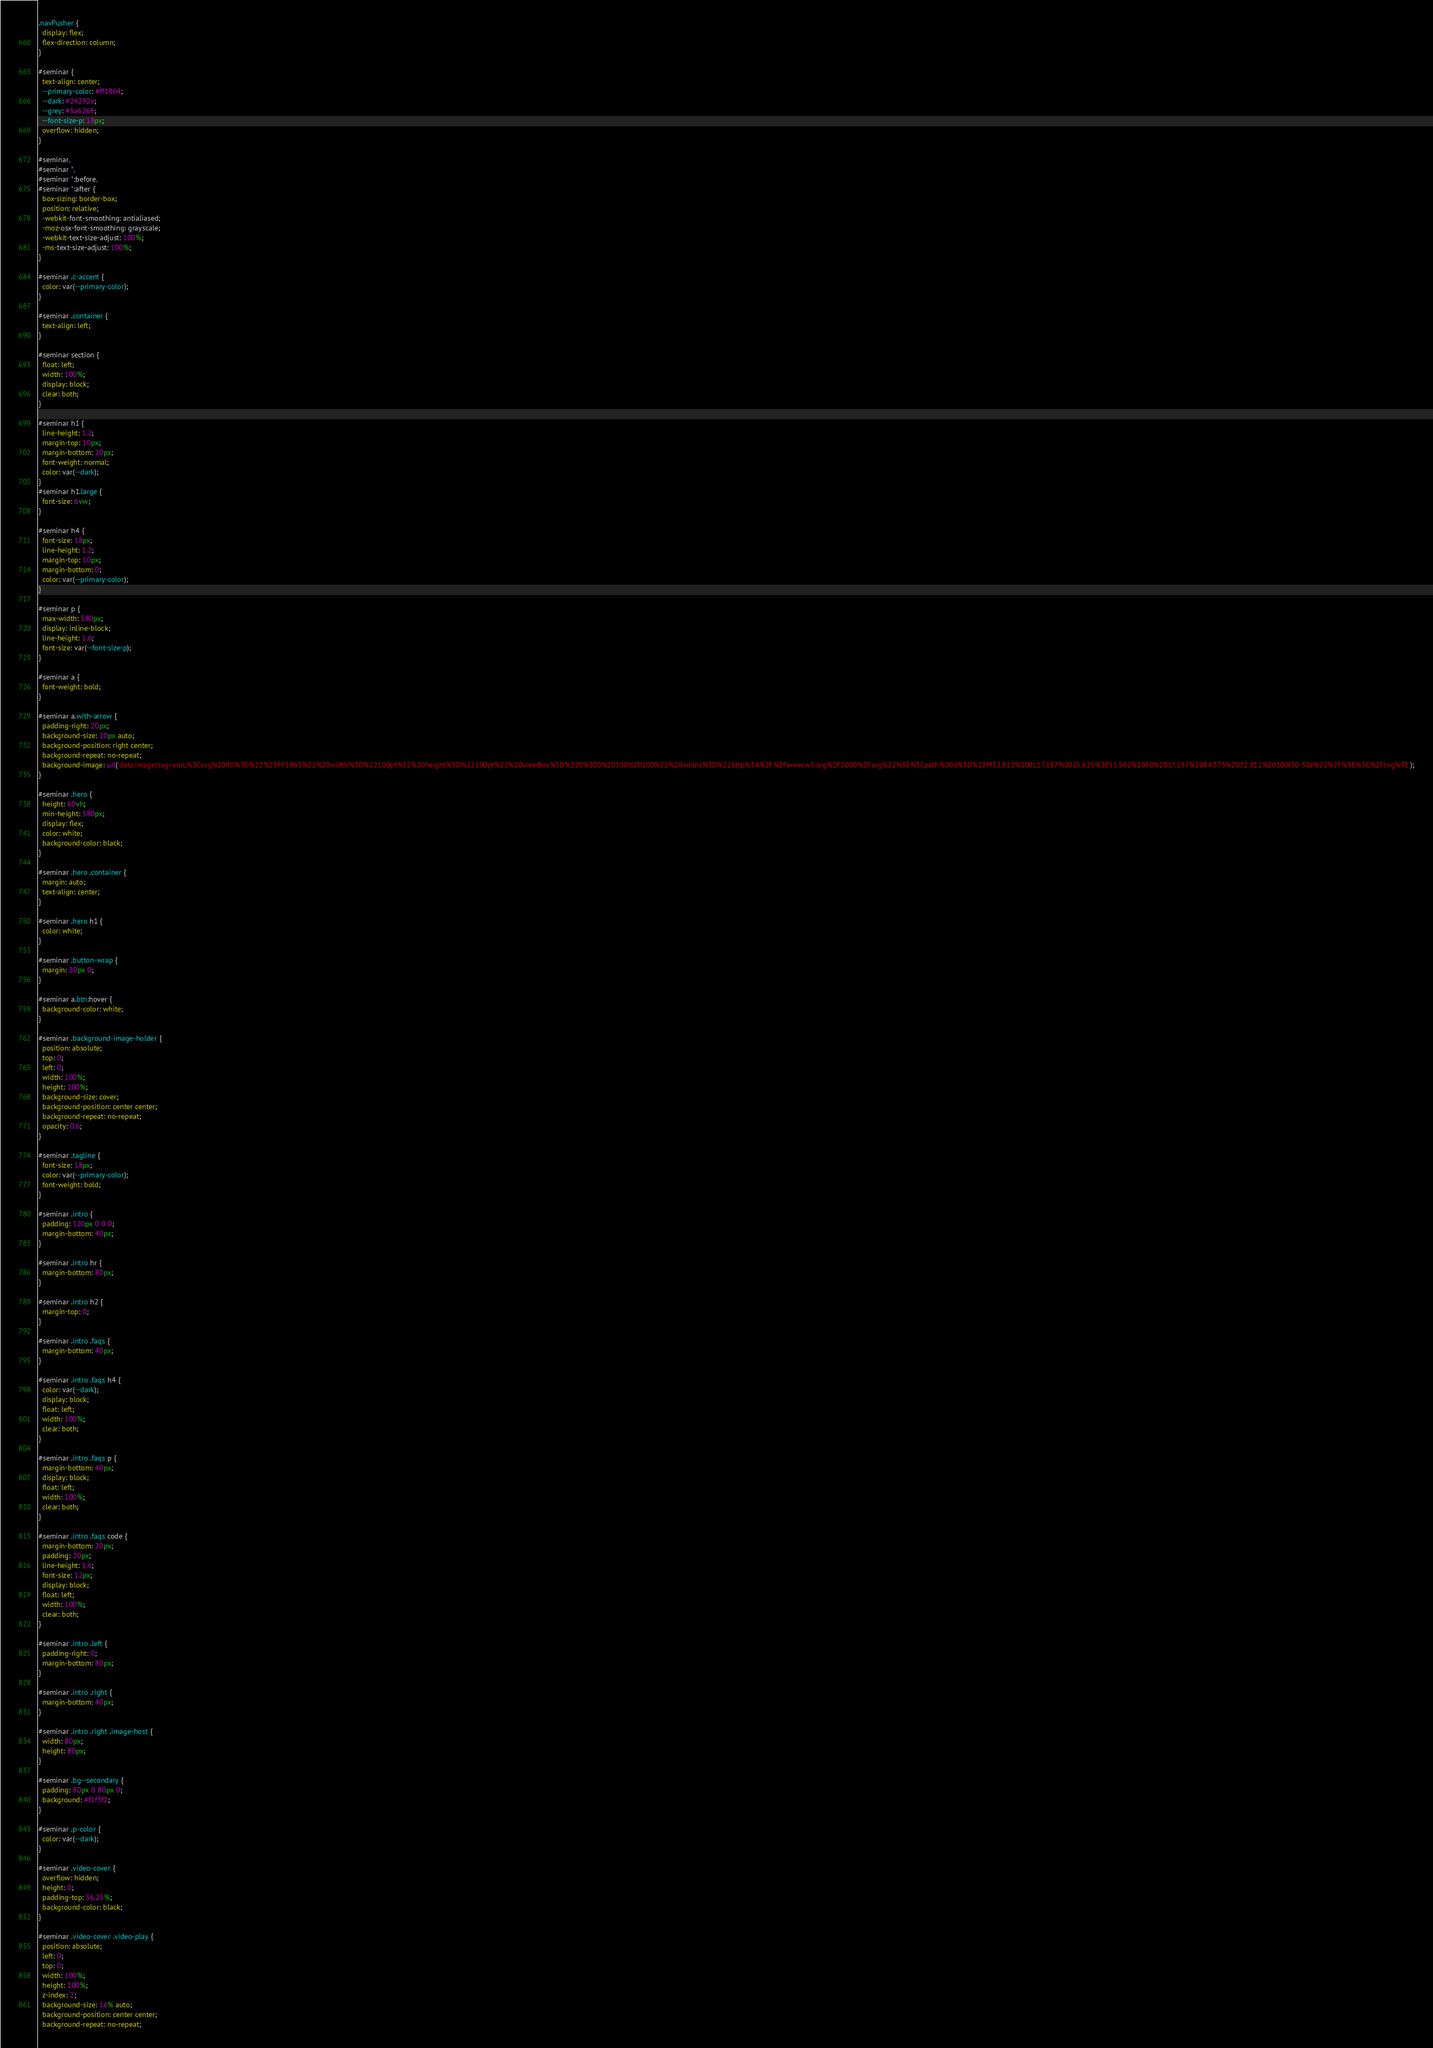<code> <loc_0><loc_0><loc_500><loc_500><_CSS_>.navPusher {
  display: flex;
  flex-direction: column;
}

#seminar {
  text-align: center;
  --primary-color: #ff1864;
  --dark: #24292e;
  --grey: #5a6268;
  --font-size-p: 18px;
  overflow: hidden;
}

#seminar,
#seminar *,
#seminar *:before,
#seminar *:after {
  box-sizing: border-box;
  position: relative;
  -webkit-font-smoothing: antialiased;
  -moz-osx-font-smoothing: grayscale;
  -webkit-text-size-adjust: 100%;
  -ms-text-size-adjust: 100%;
}

#seminar .c-accent {
  color: var(--primary-color);
}

#seminar .container {
  text-align: left;
}

#seminar section {
  float: left;
  width: 100%;
  display: block;
  clear: both;
}

#seminar h1 {
  line-height: 1.2;
  margin-top: 10px;
  margin-bottom: 20px;
  font-weight: normal;
  color: var(--dark);
}
#seminar h1.large {
  font-size: 6vw;
}

#seminar h4 {
  font-size: 18px;
  line-height: 1.2;
  margin-top: 10px;
  margin-bottom: 0;
  color: var(--primary-color);
}

#seminar p {
  max-width: 580px;
  display: inline-block;
  line-height: 1.6;
  font-size: var(--font-size-p);
}

#seminar a {
  font-weight: bold;
}

#seminar a.with-arrow {
  padding-right: 20px;
  background-size: 10px auto;
  background-position: right center;
  background-repeat: no-repeat;
  background-image: url('data:image/svg+xml,%3Csvg%20fill%3D%22%23FF1865%22%20width%3D%22100pt%22%20height%3D%22100pt%22%20viewBox%3D%220%200%20100%20100%22%20xmlns%3D%22http%3A%2F%2Fwww.w3.org%2F2000%2Fsvg%22%3E%3Cpath%20d%3D%22M32.812%200L17.187%2015.625%2051.562%2050%2017.187%2084.375%2032.812%20100l50-50z%22%2F%3E%3C%2Fsvg%3E');
}

#seminar .hero {
  height: 60vh;
  min-height: 580px;
  display: flex;
  color: white;
  background-color: black;
}

#seminar .hero .container {
  margin: auto;
  text-align: center;
}

#seminar .hero h1 {
  color: white;
}

#seminar .button-wrap {
  margin: 20px 0;
}

#seminar a.btn:hover {
  background-color: white;
}

#seminar .background-image-holder {
  position: absolute;
  top: 0;
  left: 0;
  width: 100%;
  height: 100%;
  background-size: cover;
  background-position: center center;
  background-repeat: no-repeat;
  opacity: 0.6;
}

#seminar .tagline {
  font-size: 18px;
  color: var(--primary-color);
  font-weight: bold;
}

#seminar .intro {
  padding: 120px 0 0 0;
  margin-bottom: 40px;
}

#seminar .intro hr {
  margin-bottom: 80px;
}

#seminar .intro h2 {
  margin-top: 0;
}

#seminar .intro .faqs {
  margin-bottom: 40px;
}

#seminar .intro .faqs h4 {
  color: var(--dark);
  display: block;
  float: left;
  width: 100%;
  clear: both;
}

#seminar .intro .faqs p {
  margin-bottom: 40px;
  display: block;
  float: left;
  width: 100%;
  clear: both;
}

#seminar .intro .faqs code {
  margin-bottom: 20px;
  padding: 20px;
  line-height: 1.6;
  font-size: 12px;
  display: block;
  float: left;
  width: 100%;
  clear: both;
}

#seminar .intro .left {
  padding-right: 0;
  margin-bottom: 80px;
}

#seminar .intro .right {
  margin-bottom: 40px;
}

#seminar .intro .right .image-host {
  width: 80px;
  height: 80px;
}

#seminar .bg--secondary {
  padding: 80px 0 80px 0;
  background: #f1f3f2;
}

#seminar .p-color {
  color: var(--dark);
}

#seminar .video-cover {
  overflow: hidden;
  height: 0;
  padding-top: 56.25%;
  background-color: black;
}

#seminar .video-cover .video-play {
  position: absolute;
  left: 0;
  top: 0;
  width: 100%;
  height: 100%;
  z-index: 2;
  background-size: 16% auto;
  background-position: center center;
  background-repeat: no-repeat;
</code> 